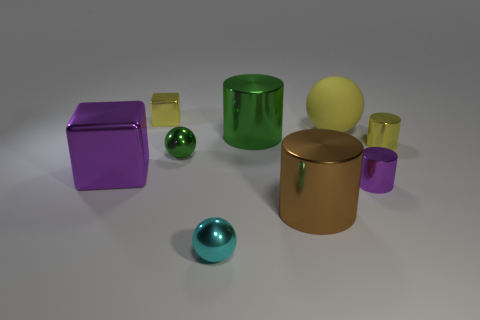Subtract all green metallic spheres. How many spheres are left? 2 Subtract all yellow cylinders. How many cylinders are left? 3 Subtract all cyan cylinders. Subtract all blue blocks. How many cylinders are left? 4 Subtract all cylinders. How many objects are left? 5 Add 3 tiny green metal things. How many tiny green metal things exist? 4 Subtract 1 yellow balls. How many objects are left? 8 Subtract all big brown cylinders. Subtract all large green shiny cubes. How many objects are left? 8 Add 7 large green cylinders. How many large green cylinders are left? 8 